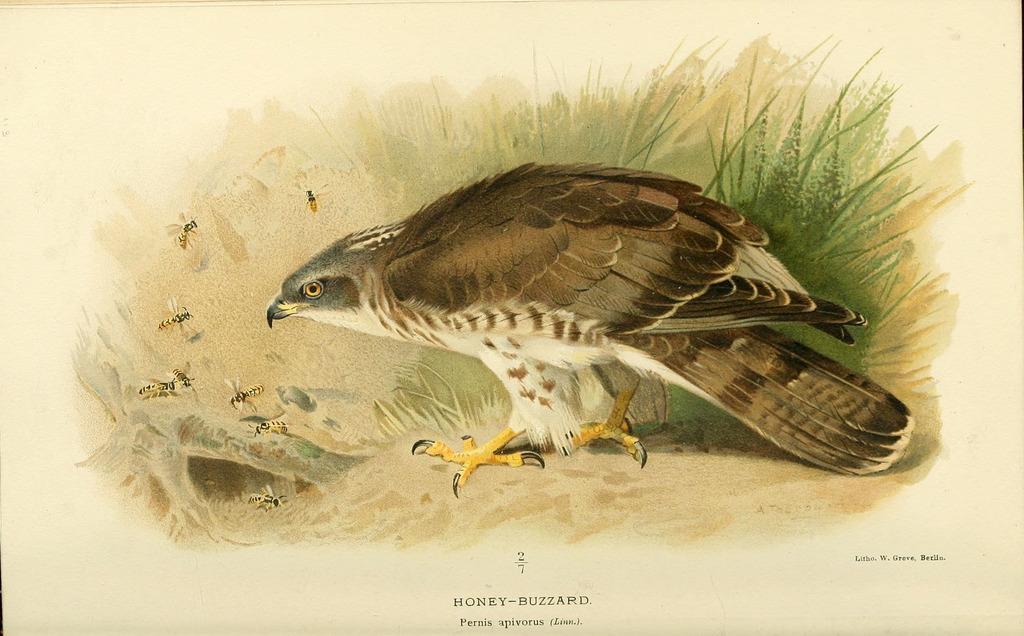In one or two sentences, can you explain what this image depicts? In the image there is a painting of a bird, honey bees and leaves. Below the painting there is something written on it. 